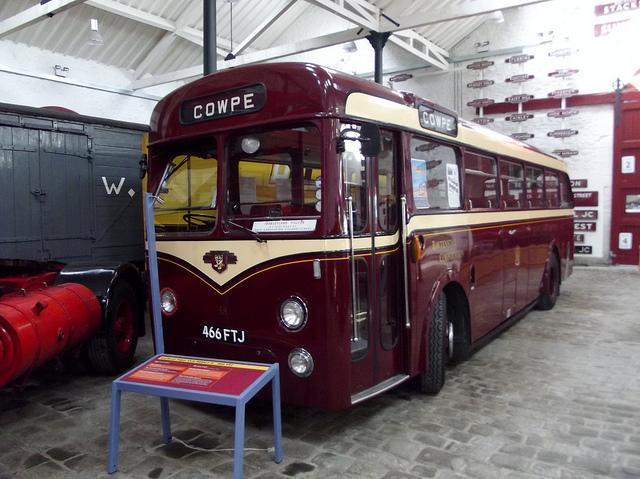How many benches are there?
Give a very brief answer. 0. 